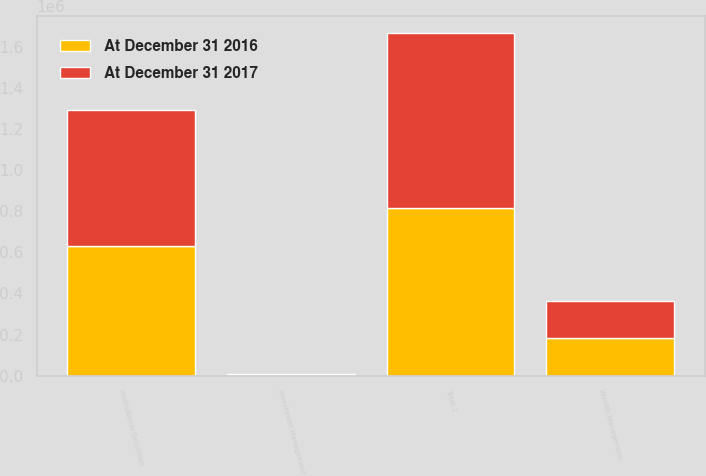<chart> <loc_0><loc_0><loc_500><loc_500><stacked_bar_chart><ecel><fcel>Institutional Securities<fcel>Wealth Management<fcel>Investment Management<fcel>Total 1<nl><fcel>At December 31 2017<fcel>664974<fcel>182009<fcel>4750<fcel>851733<nl><fcel>At December 31 2016<fcel>629149<fcel>181135<fcel>4665<fcel>814949<nl></chart> 